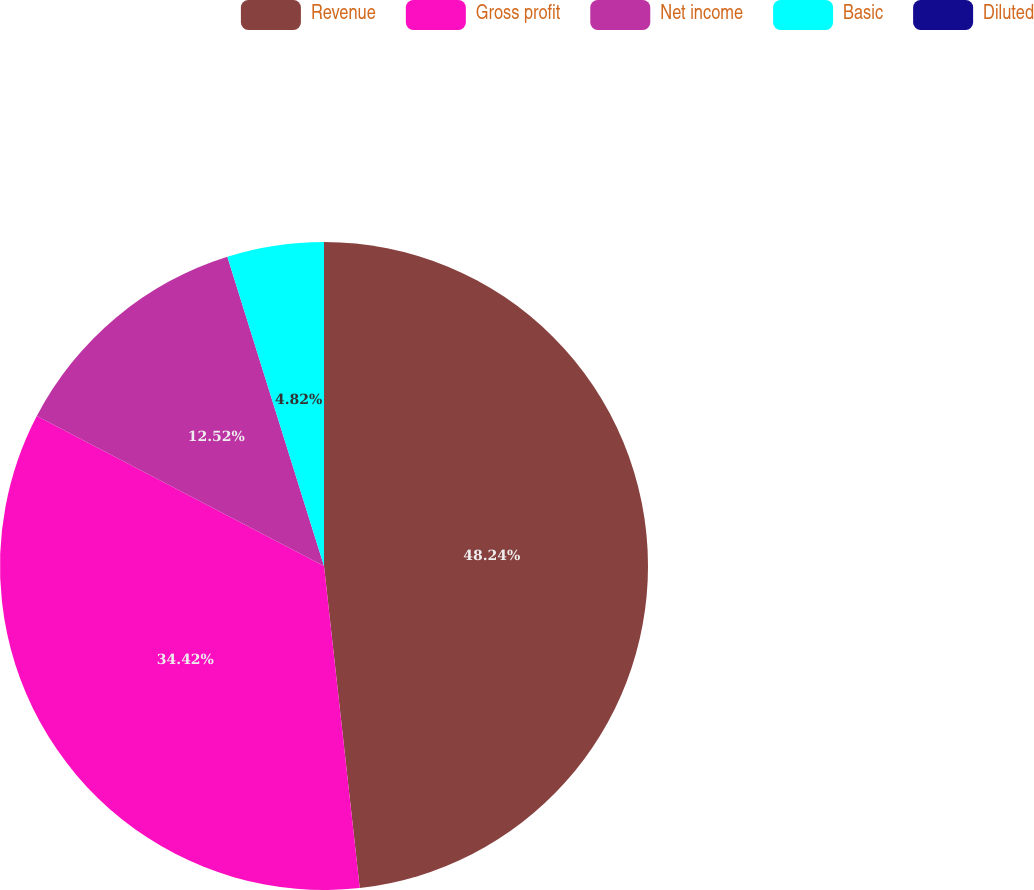<chart> <loc_0><loc_0><loc_500><loc_500><pie_chart><fcel>Revenue<fcel>Gross profit<fcel>Net income<fcel>Basic<fcel>Diluted<nl><fcel>48.24%<fcel>34.42%<fcel>12.52%<fcel>4.82%<fcel>0.0%<nl></chart> 